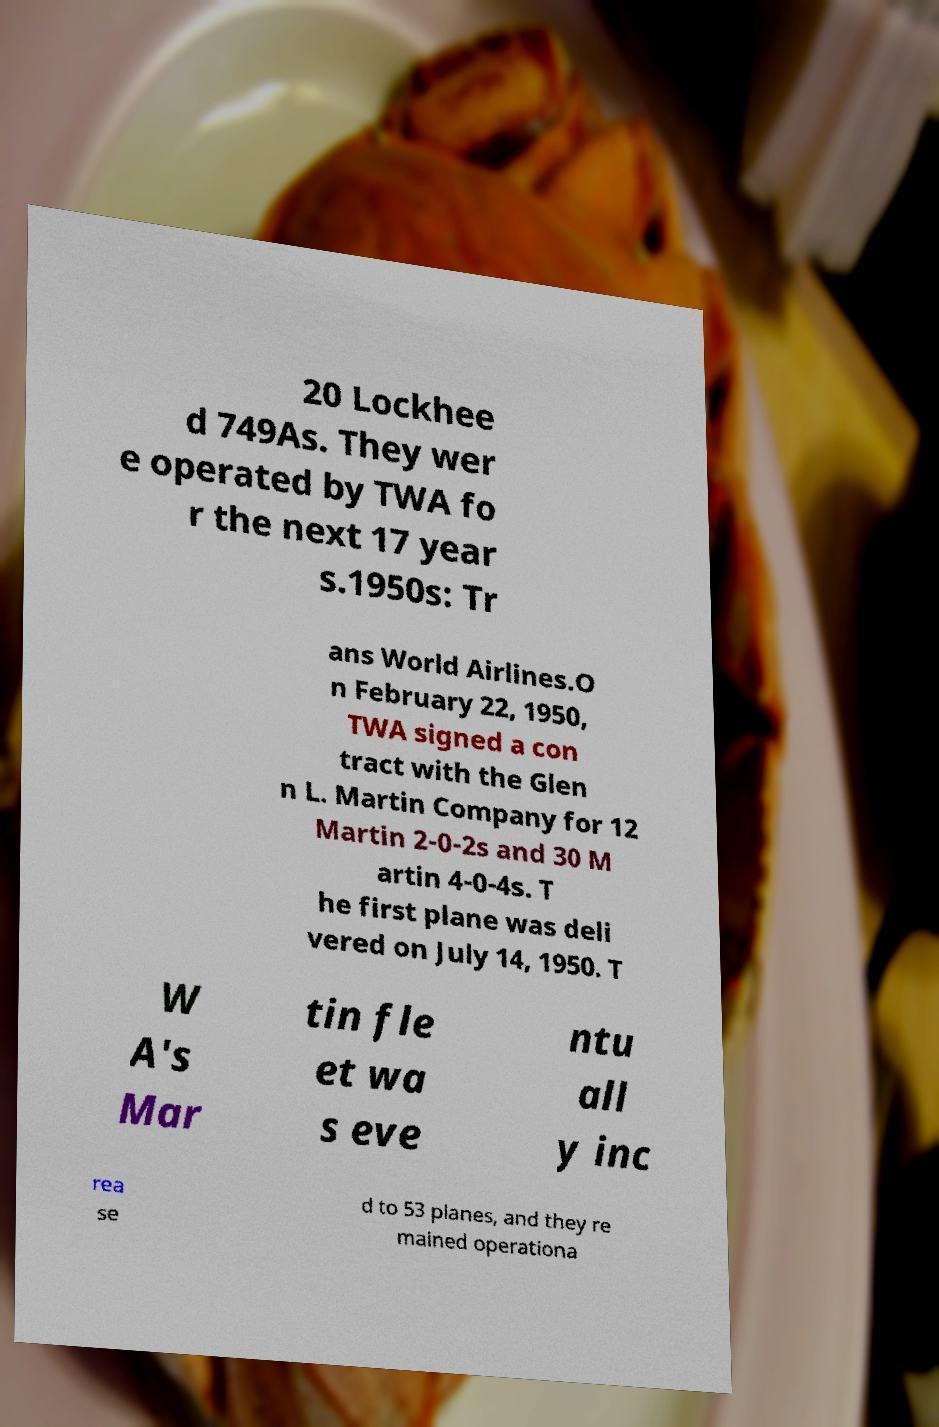Please read and relay the text visible in this image. What does it say? 20 Lockhee d 749As. They wer e operated by TWA fo r the next 17 year s.1950s: Tr ans World Airlines.O n February 22, 1950, TWA signed a con tract with the Glen n L. Martin Company for 12 Martin 2-0-2s and 30 M artin 4-0-4s. T he first plane was deli vered on July 14, 1950. T W A's Mar tin fle et wa s eve ntu all y inc rea se d to 53 planes, and they re mained operationa 